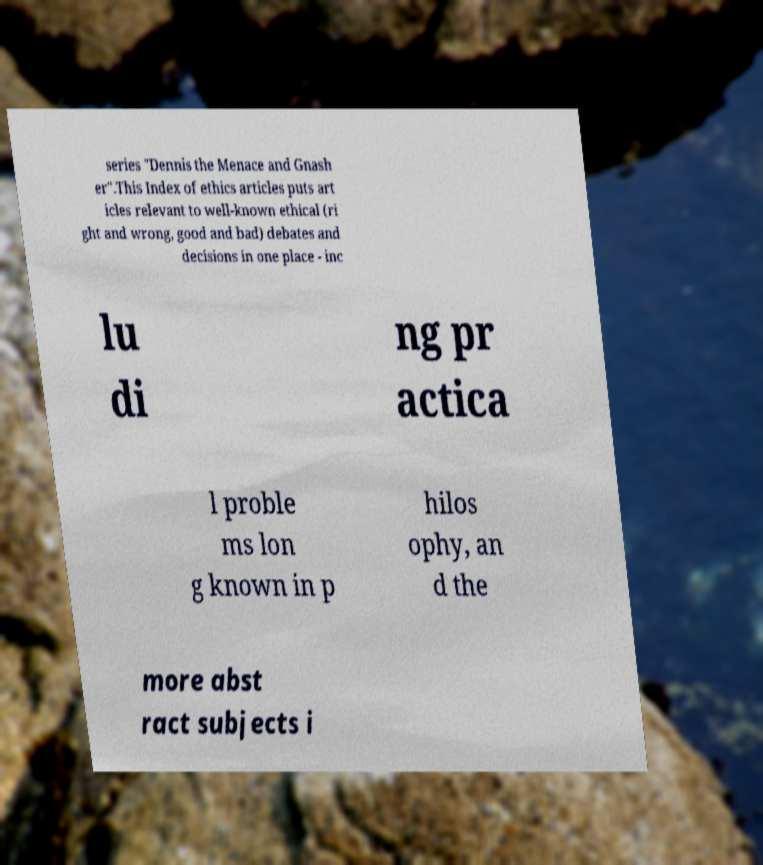For documentation purposes, I need the text within this image transcribed. Could you provide that? series "Dennis the Menace and Gnash er".This Index of ethics articles puts art icles relevant to well-known ethical (ri ght and wrong, good and bad) debates and decisions in one place - inc lu di ng pr actica l proble ms lon g known in p hilos ophy, an d the more abst ract subjects i 